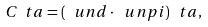Convert formula to latex. <formula><loc_0><loc_0><loc_500><loc_500>C _ { \ } t a = ( \ u n d \cdot \ u n p i ) _ { \ } t a ,</formula> 